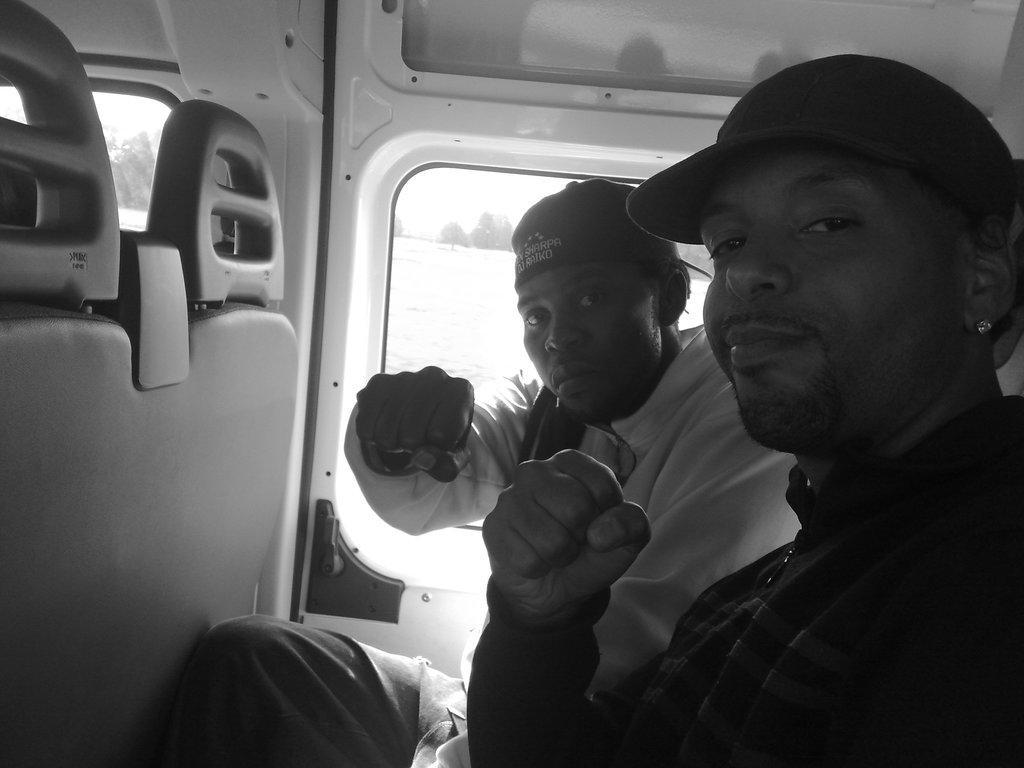Could you give a brief overview of what you see in this image? This is a black and white picture. The man in the black jacket and the man in the white shirt is sitting on the seats of the white vehicle. Both of them are posing for the photo. From the window of the vehicle, we can see trees in the background. 